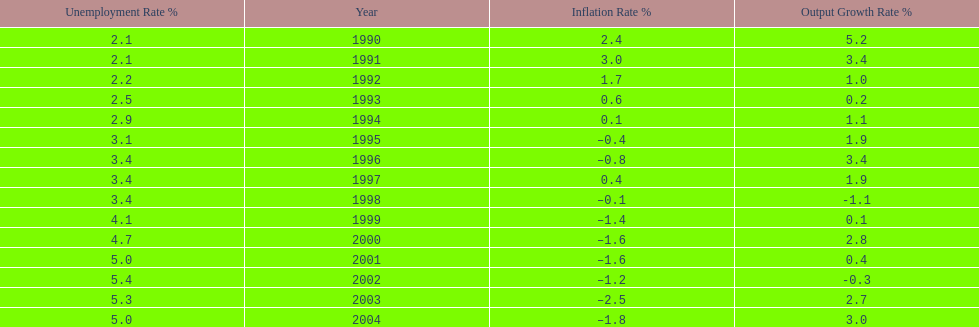Could you help me parse every detail presented in this table? {'header': ['Unemployment Rate\xa0%', 'Year', 'Inflation Rate\xa0%', 'Output Growth Rate\xa0%'], 'rows': [['2.1', '1990', '2.4', '5.2'], ['2.1', '1991', '3.0', '3.4'], ['2.2', '1992', '1.7', '1.0'], ['2.5', '1993', '0.6', '0.2'], ['2.9', '1994', '0.1', '1.1'], ['3.1', '1995', '–0.4', '1.9'], ['3.4', '1996', '–0.8', '3.4'], ['3.4', '1997', '0.4', '1.9'], ['3.4', '1998', '–0.1', '-1.1'], ['4.1', '1999', '–1.4', '0.1'], ['4.7', '2000', '–1.6', '2.8'], ['5.0', '2001', '–1.6', '0.4'], ['5.4', '2002', '–1.2', '-0.3'], ['5.3', '2003', '–2.5', '2.7'], ['5.0', '2004', '–1.8', '3.0']]} Were the highest unemployment rates in japan before or after the year 2000? After. 